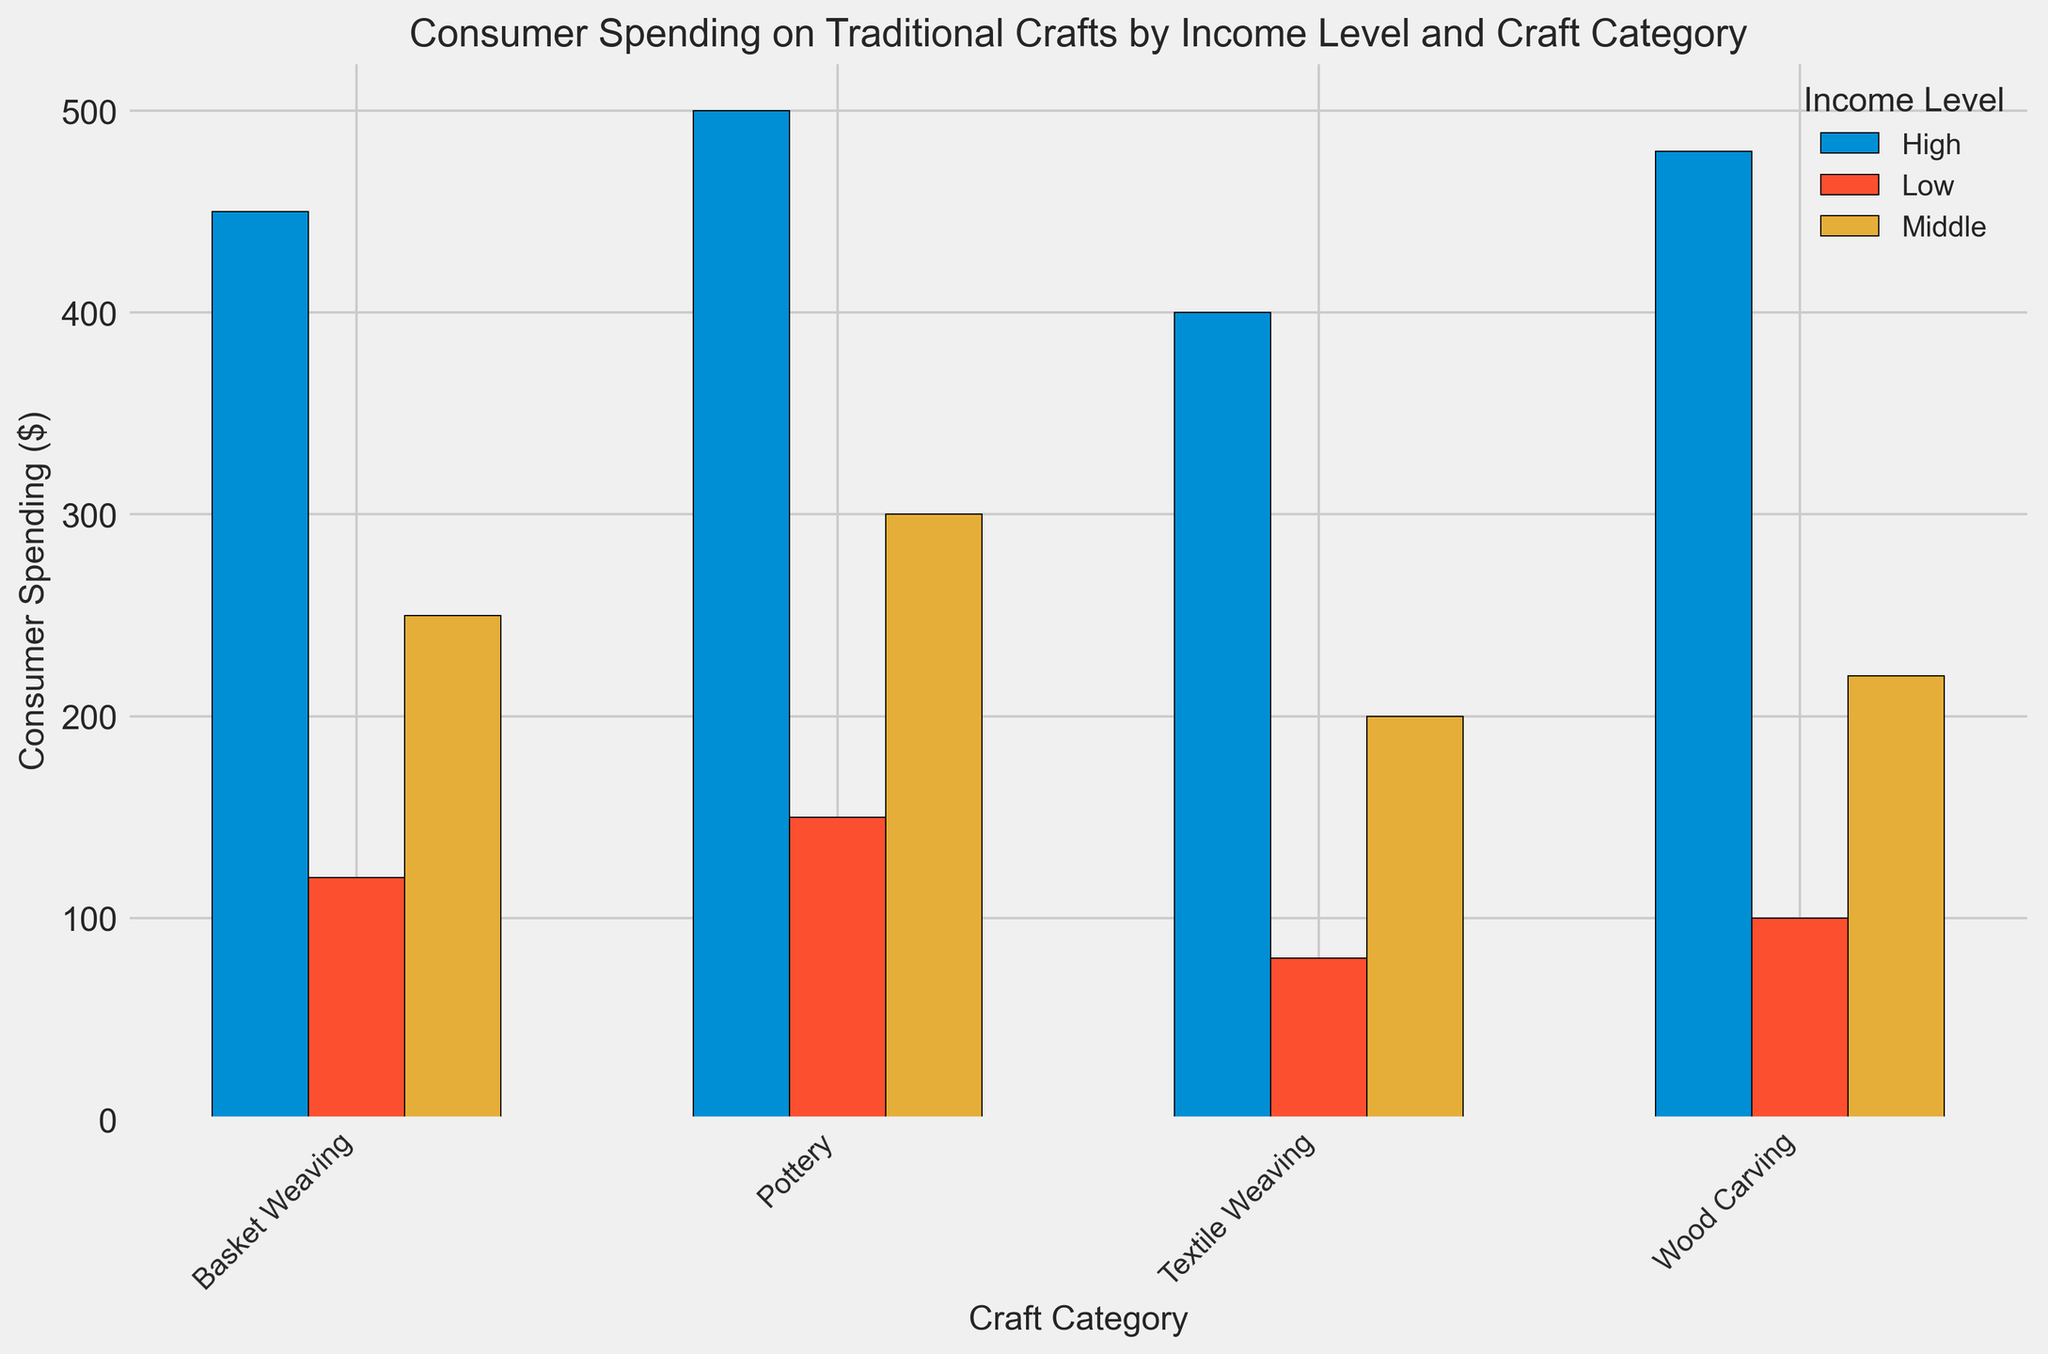What is the total consumer spending on Basket Weaving across all income levels? To find the total spending on Basket Weaving, sum the spending of all income levels: 120 (Low) + 250 (Middle) + 450 (High) = 820.
Answer: 820 Which craft category has the highest consumer spending in the High-income level? The consumer spending in the High-income level is highest for Pottery at $500.
Answer: Pottery Is consumer spending on Wood Carving in the Middle-income level higher or lower than in the Low-income level? The spending on Wood Carving is $220 for Middle-income and $100 for Low-income. Since $220 > $100, it is higher in the Middle-income level.
Answer: Higher What is the difference in consumer spending on Textile Weaving between the High-income and Low-income levels? Spending on Textile Weaving is $400 for High-income and $80 for Low-income. The difference is $400 - $80 = $320.
Answer: 320 Which income level has the most diverse spending across different craft categories? To determine this, we look at the range of spending within each income level:
- Low: 80 (Textile Weaving) to 150 (Pottery), range = 150 - 80 = 70
- Middle: 200 (Textile Weaving) to 300 (Pottery), range = 300 - 200 = 100
- High: 400 (Textile Weaving) to 500 (Pottery), range = 500 - 400 = 100
Both Middle and High-income levels have the same range (100), indicating the most diverse spending.
Answer: Middle and High Which craft category has the smallest spending difference between the High and Middle-income levels? Calculate the differences for each category:
- Basket Weaving: 450 - 250 = 200
- Pottery: 500 - 300 = 200
- Textile Weaving: 400 - 200 = 200
- Wood Carving: 480 - 220 = 260
The smallest difference is 200 (Basket Weaving, Pottery, and Textile Weaving).
Answer: Basket Weaving, Pottery, Textile Weaving What is the average consumer spending on Pottery across all income levels? Average spending is calculated by summing the spending across all levels and dividing by the number of income levels: (150 + 300 + 500) / 3 = 950 / 3 ≈ 316.67.
Answer: 316.67 In which income level is consumer spending for Craft Categories more balanced (i.e., less spread out)? Examine the differences within each income level:
- Low: Spendings are 120, 150, 80, 100; range 70
- Middle: Spendings are 250, 300, 200, 220; range 100
- High: Spendings are 450, 500, 400, 480; range 100
The Low-income level has the smallest range (70), indicating more balanced spending.
Answer: Low 